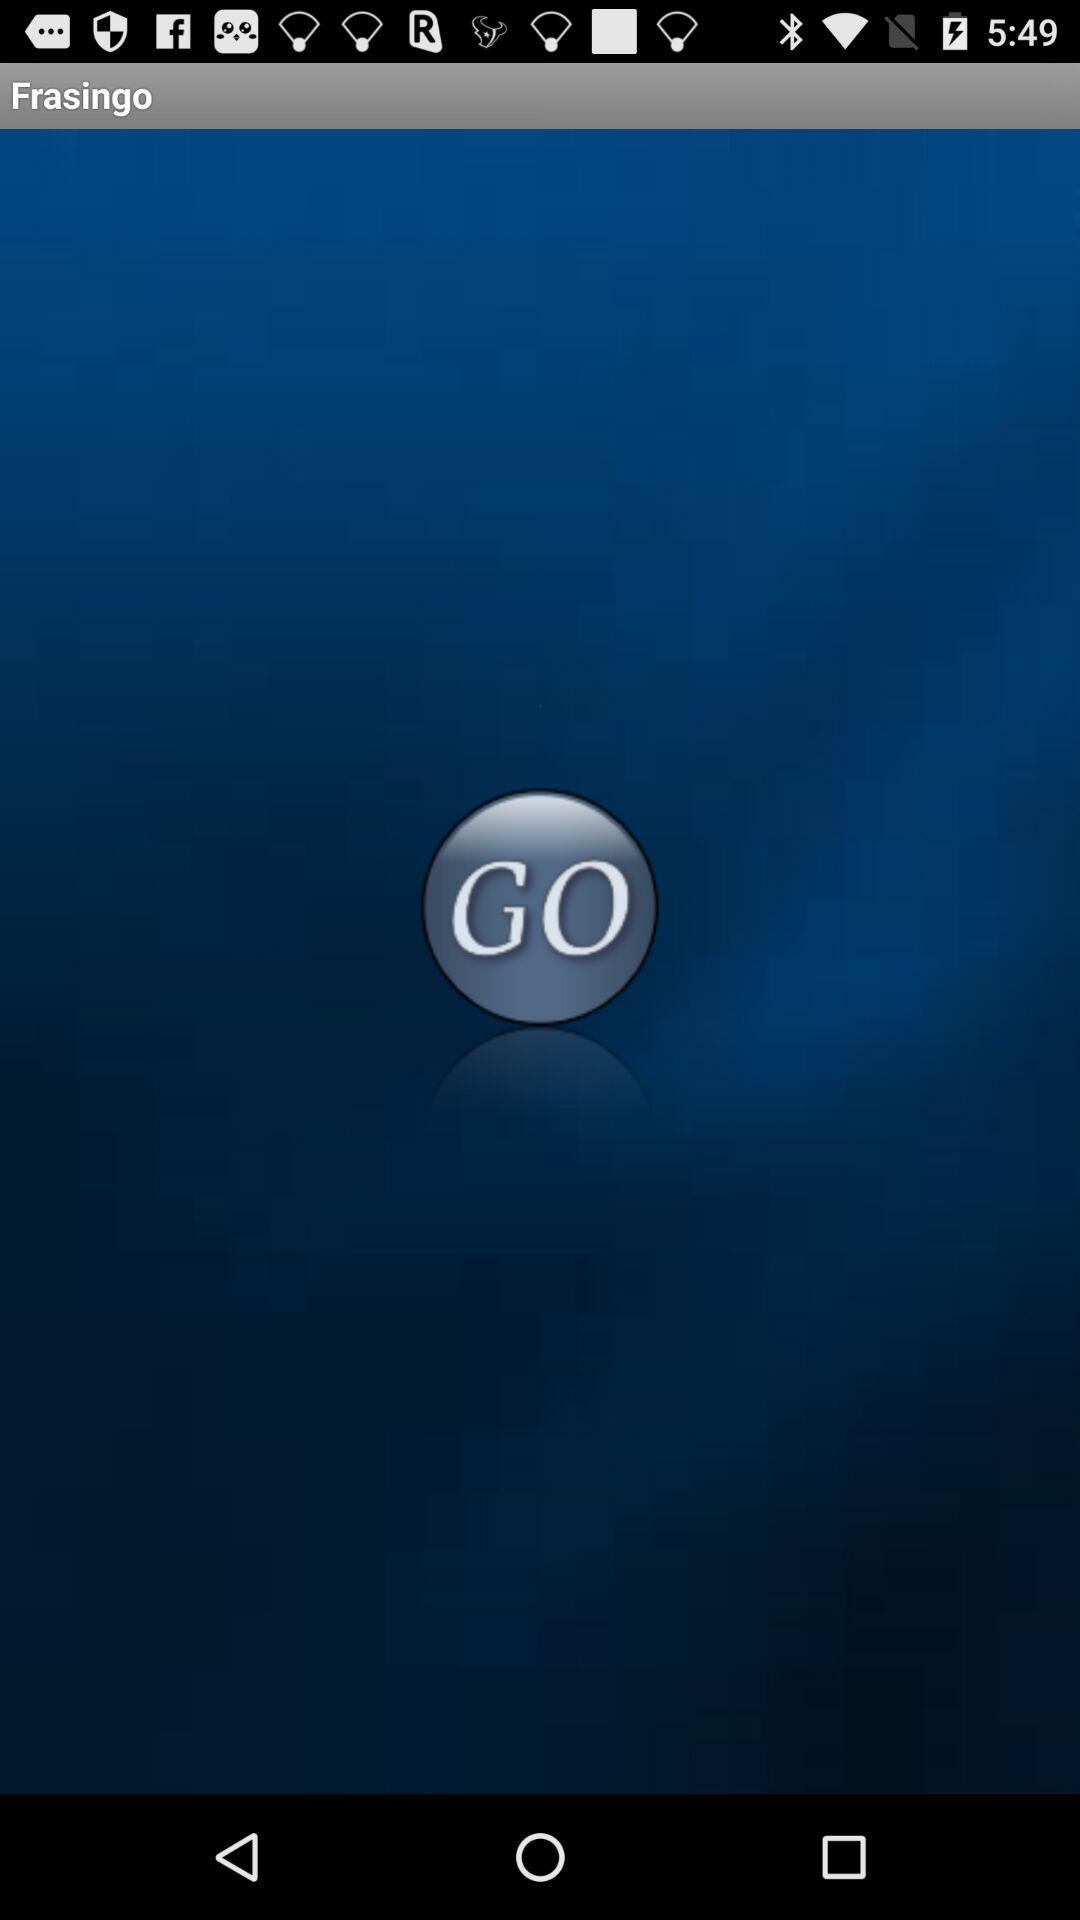What is the application name? The application name is "Frasingo". 